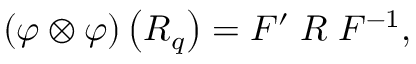<formula> <loc_0><loc_0><loc_500><loc_500>\left ( \varphi \otimes \varphi \right ) \left ( R _ { q } \right ) = F ^ { \prime } \, R \, F ^ { - 1 } ,</formula> 